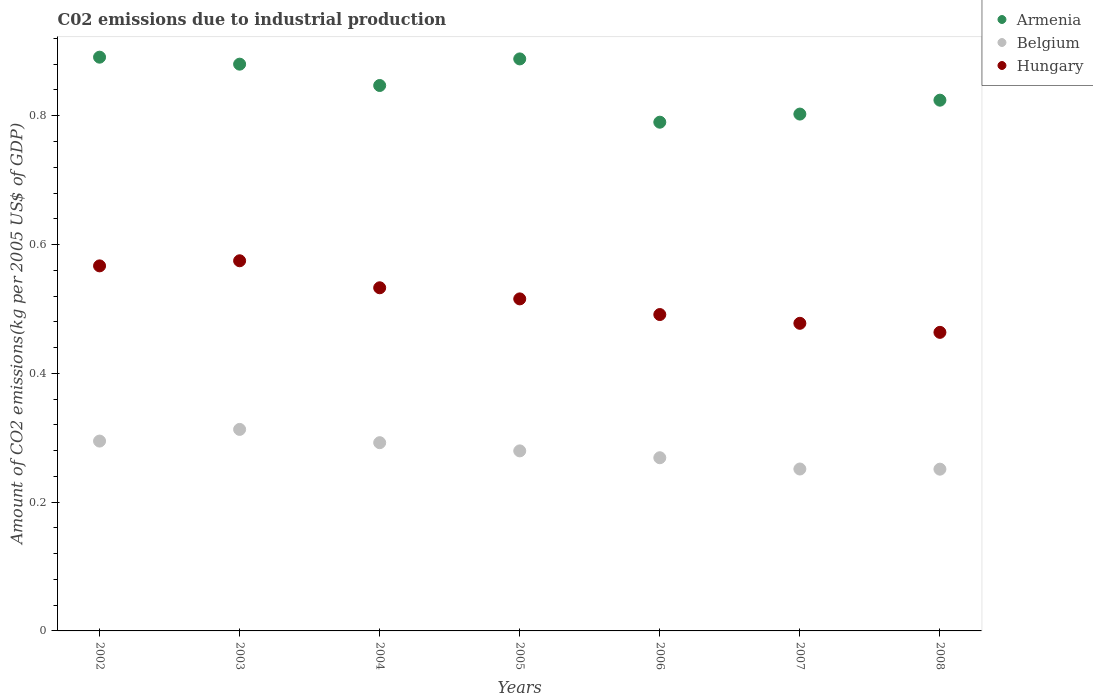Is the number of dotlines equal to the number of legend labels?
Offer a terse response. Yes. What is the amount of CO2 emitted due to industrial production in Belgium in 2005?
Your answer should be compact. 0.28. Across all years, what is the maximum amount of CO2 emitted due to industrial production in Hungary?
Your response must be concise. 0.57. Across all years, what is the minimum amount of CO2 emitted due to industrial production in Belgium?
Provide a succinct answer. 0.25. In which year was the amount of CO2 emitted due to industrial production in Belgium minimum?
Provide a short and direct response. 2008. What is the total amount of CO2 emitted due to industrial production in Armenia in the graph?
Make the answer very short. 5.92. What is the difference between the amount of CO2 emitted due to industrial production in Hungary in 2003 and that in 2006?
Your answer should be compact. 0.08. What is the difference between the amount of CO2 emitted due to industrial production in Armenia in 2003 and the amount of CO2 emitted due to industrial production in Belgium in 2007?
Offer a terse response. 0.63. What is the average amount of CO2 emitted due to industrial production in Belgium per year?
Make the answer very short. 0.28. In the year 2003, what is the difference between the amount of CO2 emitted due to industrial production in Hungary and amount of CO2 emitted due to industrial production in Belgium?
Your answer should be compact. 0.26. In how many years, is the amount of CO2 emitted due to industrial production in Belgium greater than 0.6400000000000001 kg?
Ensure brevity in your answer.  0. What is the ratio of the amount of CO2 emitted due to industrial production in Hungary in 2004 to that in 2007?
Your response must be concise. 1.12. Is the amount of CO2 emitted due to industrial production in Armenia in 2004 less than that in 2007?
Keep it short and to the point. No. Is the difference between the amount of CO2 emitted due to industrial production in Hungary in 2006 and 2007 greater than the difference between the amount of CO2 emitted due to industrial production in Belgium in 2006 and 2007?
Provide a short and direct response. No. What is the difference between the highest and the second highest amount of CO2 emitted due to industrial production in Belgium?
Provide a short and direct response. 0.02. What is the difference between the highest and the lowest amount of CO2 emitted due to industrial production in Armenia?
Make the answer very short. 0.1. In how many years, is the amount of CO2 emitted due to industrial production in Belgium greater than the average amount of CO2 emitted due to industrial production in Belgium taken over all years?
Your answer should be very brief. 4. Does the amount of CO2 emitted due to industrial production in Armenia monotonically increase over the years?
Ensure brevity in your answer.  No. Does the graph contain grids?
Provide a short and direct response. No. How are the legend labels stacked?
Your answer should be very brief. Vertical. What is the title of the graph?
Ensure brevity in your answer.  C02 emissions due to industrial production. What is the label or title of the Y-axis?
Ensure brevity in your answer.  Amount of CO2 emissions(kg per 2005 US$ of GDP). What is the Amount of CO2 emissions(kg per 2005 US$ of GDP) of Armenia in 2002?
Ensure brevity in your answer.  0.89. What is the Amount of CO2 emissions(kg per 2005 US$ of GDP) of Belgium in 2002?
Provide a succinct answer. 0.29. What is the Amount of CO2 emissions(kg per 2005 US$ of GDP) of Hungary in 2002?
Your answer should be compact. 0.57. What is the Amount of CO2 emissions(kg per 2005 US$ of GDP) in Armenia in 2003?
Offer a very short reply. 0.88. What is the Amount of CO2 emissions(kg per 2005 US$ of GDP) in Belgium in 2003?
Make the answer very short. 0.31. What is the Amount of CO2 emissions(kg per 2005 US$ of GDP) of Hungary in 2003?
Your answer should be very brief. 0.57. What is the Amount of CO2 emissions(kg per 2005 US$ of GDP) of Armenia in 2004?
Provide a short and direct response. 0.85. What is the Amount of CO2 emissions(kg per 2005 US$ of GDP) of Belgium in 2004?
Make the answer very short. 0.29. What is the Amount of CO2 emissions(kg per 2005 US$ of GDP) in Hungary in 2004?
Your answer should be very brief. 0.53. What is the Amount of CO2 emissions(kg per 2005 US$ of GDP) in Armenia in 2005?
Your response must be concise. 0.89. What is the Amount of CO2 emissions(kg per 2005 US$ of GDP) of Belgium in 2005?
Provide a succinct answer. 0.28. What is the Amount of CO2 emissions(kg per 2005 US$ of GDP) of Hungary in 2005?
Offer a terse response. 0.52. What is the Amount of CO2 emissions(kg per 2005 US$ of GDP) of Armenia in 2006?
Make the answer very short. 0.79. What is the Amount of CO2 emissions(kg per 2005 US$ of GDP) in Belgium in 2006?
Offer a terse response. 0.27. What is the Amount of CO2 emissions(kg per 2005 US$ of GDP) of Hungary in 2006?
Ensure brevity in your answer.  0.49. What is the Amount of CO2 emissions(kg per 2005 US$ of GDP) in Armenia in 2007?
Ensure brevity in your answer.  0.8. What is the Amount of CO2 emissions(kg per 2005 US$ of GDP) in Belgium in 2007?
Offer a very short reply. 0.25. What is the Amount of CO2 emissions(kg per 2005 US$ of GDP) of Hungary in 2007?
Provide a succinct answer. 0.48. What is the Amount of CO2 emissions(kg per 2005 US$ of GDP) in Armenia in 2008?
Offer a terse response. 0.82. What is the Amount of CO2 emissions(kg per 2005 US$ of GDP) in Belgium in 2008?
Offer a very short reply. 0.25. What is the Amount of CO2 emissions(kg per 2005 US$ of GDP) in Hungary in 2008?
Keep it short and to the point. 0.46. Across all years, what is the maximum Amount of CO2 emissions(kg per 2005 US$ of GDP) in Armenia?
Offer a terse response. 0.89. Across all years, what is the maximum Amount of CO2 emissions(kg per 2005 US$ of GDP) in Belgium?
Your response must be concise. 0.31. Across all years, what is the maximum Amount of CO2 emissions(kg per 2005 US$ of GDP) of Hungary?
Make the answer very short. 0.57. Across all years, what is the minimum Amount of CO2 emissions(kg per 2005 US$ of GDP) of Armenia?
Offer a terse response. 0.79. Across all years, what is the minimum Amount of CO2 emissions(kg per 2005 US$ of GDP) in Belgium?
Ensure brevity in your answer.  0.25. Across all years, what is the minimum Amount of CO2 emissions(kg per 2005 US$ of GDP) in Hungary?
Your answer should be very brief. 0.46. What is the total Amount of CO2 emissions(kg per 2005 US$ of GDP) in Armenia in the graph?
Offer a terse response. 5.92. What is the total Amount of CO2 emissions(kg per 2005 US$ of GDP) in Belgium in the graph?
Your answer should be very brief. 1.95. What is the total Amount of CO2 emissions(kg per 2005 US$ of GDP) in Hungary in the graph?
Offer a terse response. 3.62. What is the difference between the Amount of CO2 emissions(kg per 2005 US$ of GDP) of Armenia in 2002 and that in 2003?
Your answer should be very brief. 0.01. What is the difference between the Amount of CO2 emissions(kg per 2005 US$ of GDP) in Belgium in 2002 and that in 2003?
Your answer should be compact. -0.02. What is the difference between the Amount of CO2 emissions(kg per 2005 US$ of GDP) of Hungary in 2002 and that in 2003?
Provide a short and direct response. -0.01. What is the difference between the Amount of CO2 emissions(kg per 2005 US$ of GDP) of Armenia in 2002 and that in 2004?
Your answer should be compact. 0.04. What is the difference between the Amount of CO2 emissions(kg per 2005 US$ of GDP) in Belgium in 2002 and that in 2004?
Provide a succinct answer. 0. What is the difference between the Amount of CO2 emissions(kg per 2005 US$ of GDP) in Hungary in 2002 and that in 2004?
Keep it short and to the point. 0.03. What is the difference between the Amount of CO2 emissions(kg per 2005 US$ of GDP) in Armenia in 2002 and that in 2005?
Make the answer very short. 0. What is the difference between the Amount of CO2 emissions(kg per 2005 US$ of GDP) of Belgium in 2002 and that in 2005?
Offer a terse response. 0.02. What is the difference between the Amount of CO2 emissions(kg per 2005 US$ of GDP) of Hungary in 2002 and that in 2005?
Your answer should be compact. 0.05. What is the difference between the Amount of CO2 emissions(kg per 2005 US$ of GDP) of Armenia in 2002 and that in 2006?
Make the answer very short. 0.1. What is the difference between the Amount of CO2 emissions(kg per 2005 US$ of GDP) of Belgium in 2002 and that in 2006?
Your answer should be compact. 0.03. What is the difference between the Amount of CO2 emissions(kg per 2005 US$ of GDP) of Hungary in 2002 and that in 2006?
Offer a terse response. 0.08. What is the difference between the Amount of CO2 emissions(kg per 2005 US$ of GDP) in Armenia in 2002 and that in 2007?
Give a very brief answer. 0.09. What is the difference between the Amount of CO2 emissions(kg per 2005 US$ of GDP) of Belgium in 2002 and that in 2007?
Make the answer very short. 0.04. What is the difference between the Amount of CO2 emissions(kg per 2005 US$ of GDP) of Hungary in 2002 and that in 2007?
Make the answer very short. 0.09. What is the difference between the Amount of CO2 emissions(kg per 2005 US$ of GDP) in Armenia in 2002 and that in 2008?
Offer a very short reply. 0.07. What is the difference between the Amount of CO2 emissions(kg per 2005 US$ of GDP) of Belgium in 2002 and that in 2008?
Make the answer very short. 0.04. What is the difference between the Amount of CO2 emissions(kg per 2005 US$ of GDP) in Hungary in 2002 and that in 2008?
Your answer should be compact. 0.1. What is the difference between the Amount of CO2 emissions(kg per 2005 US$ of GDP) of Armenia in 2003 and that in 2004?
Give a very brief answer. 0.03. What is the difference between the Amount of CO2 emissions(kg per 2005 US$ of GDP) of Belgium in 2003 and that in 2004?
Your response must be concise. 0.02. What is the difference between the Amount of CO2 emissions(kg per 2005 US$ of GDP) of Hungary in 2003 and that in 2004?
Your answer should be compact. 0.04. What is the difference between the Amount of CO2 emissions(kg per 2005 US$ of GDP) in Armenia in 2003 and that in 2005?
Offer a very short reply. -0.01. What is the difference between the Amount of CO2 emissions(kg per 2005 US$ of GDP) of Belgium in 2003 and that in 2005?
Your answer should be compact. 0.03. What is the difference between the Amount of CO2 emissions(kg per 2005 US$ of GDP) of Hungary in 2003 and that in 2005?
Keep it short and to the point. 0.06. What is the difference between the Amount of CO2 emissions(kg per 2005 US$ of GDP) of Armenia in 2003 and that in 2006?
Make the answer very short. 0.09. What is the difference between the Amount of CO2 emissions(kg per 2005 US$ of GDP) in Belgium in 2003 and that in 2006?
Provide a succinct answer. 0.04. What is the difference between the Amount of CO2 emissions(kg per 2005 US$ of GDP) of Hungary in 2003 and that in 2006?
Keep it short and to the point. 0.08. What is the difference between the Amount of CO2 emissions(kg per 2005 US$ of GDP) of Armenia in 2003 and that in 2007?
Your answer should be very brief. 0.08. What is the difference between the Amount of CO2 emissions(kg per 2005 US$ of GDP) in Belgium in 2003 and that in 2007?
Ensure brevity in your answer.  0.06. What is the difference between the Amount of CO2 emissions(kg per 2005 US$ of GDP) of Hungary in 2003 and that in 2007?
Give a very brief answer. 0.1. What is the difference between the Amount of CO2 emissions(kg per 2005 US$ of GDP) in Armenia in 2003 and that in 2008?
Give a very brief answer. 0.06. What is the difference between the Amount of CO2 emissions(kg per 2005 US$ of GDP) of Belgium in 2003 and that in 2008?
Offer a terse response. 0.06. What is the difference between the Amount of CO2 emissions(kg per 2005 US$ of GDP) in Hungary in 2003 and that in 2008?
Make the answer very short. 0.11. What is the difference between the Amount of CO2 emissions(kg per 2005 US$ of GDP) in Armenia in 2004 and that in 2005?
Give a very brief answer. -0.04. What is the difference between the Amount of CO2 emissions(kg per 2005 US$ of GDP) in Belgium in 2004 and that in 2005?
Offer a very short reply. 0.01. What is the difference between the Amount of CO2 emissions(kg per 2005 US$ of GDP) in Hungary in 2004 and that in 2005?
Provide a short and direct response. 0.02. What is the difference between the Amount of CO2 emissions(kg per 2005 US$ of GDP) in Armenia in 2004 and that in 2006?
Your response must be concise. 0.06. What is the difference between the Amount of CO2 emissions(kg per 2005 US$ of GDP) of Belgium in 2004 and that in 2006?
Provide a succinct answer. 0.02. What is the difference between the Amount of CO2 emissions(kg per 2005 US$ of GDP) of Hungary in 2004 and that in 2006?
Offer a very short reply. 0.04. What is the difference between the Amount of CO2 emissions(kg per 2005 US$ of GDP) in Armenia in 2004 and that in 2007?
Make the answer very short. 0.04. What is the difference between the Amount of CO2 emissions(kg per 2005 US$ of GDP) of Belgium in 2004 and that in 2007?
Your response must be concise. 0.04. What is the difference between the Amount of CO2 emissions(kg per 2005 US$ of GDP) in Hungary in 2004 and that in 2007?
Your response must be concise. 0.06. What is the difference between the Amount of CO2 emissions(kg per 2005 US$ of GDP) in Armenia in 2004 and that in 2008?
Your answer should be compact. 0.02. What is the difference between the Amount of CO2 emissions(kg per 2005 US$ of GDP) of Belgium in 2004 and that in 2008?
Your answer should be compact. 0.04. What is the difference between the Amount of CO2 emissions(kg per 2005 US$ of GDP) in Hungary in 2004 and that in 2008?
Your answer should be compact. 0.07. What is the difference between the Amount of CO2 emissions(kg per 2005 US$ of GDP) of Armenia in 2005 and that in 2006?
Keep it short and to the point. 0.1. What is the difference between the Amount of CO2 emissions(kg per 2005 US$ of GDP) of Belgium in 2005 and that in 2006?
Your answer should be compact. 0.01. What is the difference between the Amount of CO2 emissions(kg per 2005 US$ of GDP) in Hungary in 2005 and that in 2006?
Offer a terse response. 0.02. What is the difference between the Amount of CO2 emissions(kg per 2005 US$ of GDP) of Armenia in 2005 and that in 2007?
Offer a very short reply. 0.09. What is the difference between the Amount of CO2 emissions(kg per 2005 US$ of GDP) of Belgium in 2005 and that in 2007?
Your response must be concise. 0.03. What is the difference between the Amount of CO2 emissions(kg per 2005 US$ of GDP) of Hungary in 2005 and that in 2007?
Your answer should be very brief. 0.04. What is the difference between the Amount of CO2 emissions(kg per 2005 US$ of GDP) in Armenia in 2005 and that in 2008?
Make the answer very short. 0.06. What is the difference between the Amount of CO2 emissions(kg per 2005 US$ of GDP) in Belgium in 2005 and that in 2008?
Keep it short and to the point. 0.03. What is the difference between the Amount of CO2 emissions(kg per 2005 US$ of GDP) in Hungary in 2005 and that in 2008?
Give a very brief answer. 0.05. What is the difference between the Amount of CO2 emissions(kg per 2005 US$ of GDP) in Armenia in 2006 and that in 2007?
Your response must be concise. -0.01. What is the difference between the Amount of CO2 emissions(kg per 2005 US$ of GDP) in Belgium in 2006 and that in 2007?
Your answer should be very brief. 0.02. What is the difference between the Amount of CO2 emissions(kg per 2005 US$ of GDP) in Hungary in 2006 and that in 2007?
Offer a very short reply. 0.01. What is the difference between the Amount of CO2 emissions(kg per 2005 US$ of GDP) in Armenia in 2006 and that in 2008?
Your response must be concise. -0.03. What is the difference between the Amount of CO2 emissions(kg per 2005 US$ of GDP) of Belgium in 2006 and that in 2008?
Keep it short and to the point. 0.02. What is the difference between the Amount of CO2 emissions(kg per 2005 US$ of GDP) of Hungary in 2006 and that in 2008?
Your answer should be very brief. 0.03. What is the difference between the Amount of CO2 emissions(kg per 2005 US$ of GDP) in Armenia in 2007 and that in 2008?
Ensure brevity in your answer.  -0.02. What is the difference between the Amount of CO2 emissions(kg per 2005 US$ of GDP) in Belgium in 2007 and that in 2008?
Give a very brief answer. 0. What is the difference between the Amount of CO2 emissions(kg per 2005 US$ of GDP) of Hungary in 2007 and that in 2008?
Your answer should be compact. 0.01. What is the difference between the Amount of CO2 emissions(kg per 2005 US$ of GDP) of Armenia in 2002 and the Amount of CO2 emissions(kg per 2005 US$ of GDP) of Belgium in 2003?
Offer a terse response. 0.58. What is the difference between the Amount of CO2 emissions(kg per 2005 US$ of GDP) in Armenia in 2002 and the Amount of CO2 emissions(kg per 2005 US$ of GDP) in Hungary in 2003?
Your answer should be compact. 0.32. What is the difference between the Amount of CO2 emissions(kg per 2005 US$ of GDP) in Belgium in 2002 and the Amount of CO2 emissions(kg per 2005 US$ of GDP) in Hungary in 2003?
Your answer should be compact. -0.28. What is the difference between the Amount of CO2 emissions(kg per 2005 US$ of GDP) in Armenia in 2002 and the Amount of CO2 emissions(kg per 2005 US$ of GDP) in Belgium in 2004?
Offer a terse response. 0.6. What is the difference between the Amount of CO2 emissions(kg per 2005 US$ of GDP) in Armenia in 2002 and the Amount of CO2 emissions(kg per 2005 US$ of GDP) in Hungary in 2004?
Give a very brief answer. 0.36. What is the difference between the Amount of CO2 emissions(kg per 2005 US$ of GDP) of Belgium in 2002 and the Amount of CO2 emissions(kg per 2005 US$ of GDP) of Hungary in 2004?
Keep it short and to the point. -0.24. What is the difference between the Amount of CO2 emissions(kg per 2005 US$ of GDP) in Armenia in 2002 and the Amount of CO2 emissions(kg per 2005 US$ of GDP) in Belgium in 2005?
Make the answer very short. 0.61. What is the difference between the Amount of CO2 emissions(kg per 2005 US$ of GDP) of Armenia in 2002 and the Amount of CO2 emissions(kg per 2005 US$ of GDP) of Hungary in 2005?
Give a very brief answer. 0.38. What is the difference between the Amount of CO2 emissions(kg per 2005 US$ of GDP) of Belgium in 2002 and the Amount of CO2 emissions(kg per 2005 US$ of GDP) of Hungary in 2005?
Offer a terse response. -0.22. What is the difference between the Amount of CO2 emissions(kg per 2005 US$ of GDP) in Armenia in 2002 and the Amount of CO2 emissions(kg per 2005 US$ of GDP) in Belgium in 2006?
Your answer should be compact. 0.62. What is the difference between the Amount of CO2 emissions(kg per 2005 US$ of GDP) of Armenia in 2002 and the Amount of CO2 emissions(kg per 2005 US$ of GDP) of Hungary in 2006?
Offer a very short reply. 0.4. What is the difference between the Amount of CO2 emissions(kg per 2005 US$ of GDP) of Belgium in 2002 and the Amount of CO2 emissions(kg per 2005 US$ of GDP) of Hungary in 2006?
Offer a very short reply. -0.2. What is the difference between the Amount of CO2 emissions(kg per 2005 US$ of GDP) in Armenia in 2002 and the Amount of CO2 emissions(kg per 2005 US$ of GDP) in Belgium in 2007?
Offer a terse response. 0.64. What is the difference between the Amount of CO2 emissions(kg per 2005 US$ of GDP) in Armenia in 2002 and the Amount of CO2 emissions(kg per 2005 US$ of GDP) in Hungary in 2007?
Your answer should be compact. 0.41. What is the difference between the Amount of CO2 emissions(kg per 2005 US$ of GDP) of Belgium in 2002 and the Amount of CO2 emissions(kg per 2005 US$ of GDP) of Hungary in 2007?
Give a very brief answer. -0.18. What is the difference between the Amount of CO2 emissions(kg per 2005 US$ of GDP) in Armenia in 2002 and the Amount of CO2 emissions(kg per 2005 US$ of GDP) in Belgium in 2008?
Provide a short and direct response. 0.64. What is the difference between the Amount of CO2 emissions(kg per 2005 US$ of GDP) of Armenia in 2002 and the Amount of CO2 emissions(kg per 2005 US$ of GDP) of Hungary in 2008?
Give a very brief answer. 0.43. What is the difference between the Amount of CO2 emissions(kg per 2005 US$ of GDP) in Belgium in 2002 and the Amount of CO2 emissions(kg per 2005 US$ of GDP) in Hungary in 2008?
Keep it short and to the point. -0.17. What is the difference between the Amount of CO2 emissions(kg per 2005 US$ of GDP) in Armenia in 2003 and the Amount of CO2 emissions(kg per 2005 US$ of GDP) in Belgium in 2004?
Your answer should be compact. 0.59. What is the difference between the Amount of CO2 emissions(kg per 2005 US$ of GDP) in Armenia in 2003 and the Amount of CO2 emissions(kg per 2005 US$ of GDP) in Hungary in 2004?
Offer a terse response. 0.35. What is the difference between the Amount of CO2 emissions(kg per 2005 US$ of GDP) in Belgium in 2003 and the Amount of CO2 emissions(kg per 2005 US$ of GDP) in Hungary in 2004?
Your response must be concise. -0.22. What is the difference between the Amount of CO2 emissions(kg per 2005 US$ of GDP) in Armenia in 2003 and the Amount of CO2 emissions(kg per 2005 US$ of GDP) in Belgium in 2005?
Provide a short and direct response. 0.6. What is the difference between the Amount of CO2 emissions(kg per 2005 US$ of GDP) in Armenia in 2003 and the Amount of CO2 emissions(kg per 2005 US$ of GDP) in Hungary in 2005?
Give a very brief answer. 0.36. What is the difference between the Amount of CO2 emissions(kg per 2005 US$ of GDP) of Belgium in 2003 and the Amount of CO2 emissions(kg per 2005 US$ of GDP) of Hungary in 2005?
Your answer should be very brief. -0.2. What is the difference between the Amount of CO2 emissions(kg per 2005 US$ of GDP) of Armenia in 2003 and the Amount of CO2 emissions(kg per 2005 US$ of GDP) of Belgium in 2006?
Your answer should be compact. 0.61. What is the difference between the Amount of CO2 emissions(kg per 2005 US$ of GDP) of Armenia in 2003 and the Amount of CO2 emissions(kg per 2005 US$ of GDP) of Hungary in 2006?
Offer a very short reply. 0.39. What is the difference between the Amount of CO2 emissions(kg per 2005 US$ of GDP) of Belgium in 2003 and the Amount of CO2 emissions(kg per 2005 US$ of GDP) of Hungary in 2006?
Make the answer very short. -0.18. What is the difference between the Amount of CO2 emissions(kg per 2005 US$ of GDP) of Armenia in 2003 and the Amount of CO2 emissions(kg per 2005 US$ of GDP) of Belgium in 2007?
Provide a short and direct response. 0.63. What is the difference between the Amount of CO2 emissions(kg per 2005 US$ of GDP) in Armenia in 2003 and the Amount of CO2 emissions(kg per 2005 US$ of GDP) in Hungary in 2007?
Your answer should be very brief. 0.4. What is the difference between the Amount of CO2 emissions(kg per 2005 US$ of GDP) in Belgium in 2003 and the Amount of CO2 emissions(kg per 2005 US$ of GDP) in Hungary in 2007?
Your answer should be compact. -0.16. What is the difference between the Amount of CO2 emissions(kg per 2005 US$ of GDP) of Armenia in 2003 and the Amount of CO2 emissions(kg per 2005 US$ of GDP) of Belgium in 2008?
Your response must be concise. 0.63. What is the difference between the Amount of CO2 emissions(kg per 2005 US$ of GDP) of Armenia in 2003 and the Amount of CO2 emissions(kg per 2005 US$ of GDP) of Hungary in 2008?
Your response must be concise. 0.42. What is the difference between the Amount of CO2 emissions(kg per 2005 US$ of GDP) in Belgium in 2003 and the Amount of CO2 emissions(kg per 2005 US$ of GDP) in Hungary in 2008?
Give a very brief answer. -0.15. What is the difference between the Amount of CO2 emissions(kg per 2005 US$ of GDP) in Armenia in 2004 and the Amount of CO2 emissions(kg per 2005 US$ of GDP) in Belgium in 2005?
Your answer should be compact. 0.57. What is the difference between the Amount of CO2 emissions(kg per 2005 US$ of GDP) of Armenia in 2004 and the Amount of CO2 emissions(kg per 2005 US$ of GDP) of Hungary in 2005?
Provide a short and direct response. 0.33. What is the difference between the Amount of CO2 emissions(kg per 2005 US$ of GDP) of Belgium in 2004 and the Amount of CO2 emissions(kg per 2005 US$ of GDP) of Hungary in 2005?
Your answer should be very brief. -0.22. What is the difference between the Amount of CO2 emissions(kg per 2005 US$ of GDP) of Armenia in 2004 and the Amount of CO2 emissions(kg per 2005 US$ of GDP) of Belgium in 2006?
Give a very brief answer. 0.58. What is the difference between the Amount of CO2 emissions(kg per 2005 US$ of GDP) of Armenia in 2004 and the Amount of CO2 emissions(kg per 2005 US$ of GDP) of Hungary in 2006?
Your answer should be compact. 0.36. What is the difference between the Amount of CO2 emissions(kg per 2005 US$ of GDP) in Belgium in 2004 and the Amount of CO2 emissions(kg per 2005 US$ of GDP) in Hungary in 2006?
Give a very brief answer. -0.2. What is the difference between the Amount of CO2 emissions(kg per 2005 US$ of GDP) of Armenia in 2004 and the Amount of CO2 emissions(kg per 2005 US$ of GDP) of Belgium in 2007?
Provide a succinct answer. 0.6. What is the difference between the Amount of CO2 emissions(kg per 2005 US$ of GDP) in Armenia in 2004 and the Amount of CO2 emissions(kg per 2005 US$ of GDP) in Hungary in 2007?
Provide a short and direct response. 0.37. What is the difference between the Amount of CO2 emissions(kg per 2005 US$ of GDP) in Belgium in 2004 and the Amount of CO2 emissions(kg per 2005 US$ of GDP) in Hungary in 2007?
Offer a very short reply. -0.19. What is the difference between the Amount of CO2 emissions(kg per 2005 US$ of GDP) in Armenia in 2004 and the Amount of CO2 emissions(kg per 2005 US$ of GDP) in Belgium in 2008?
Make the answer very short. 0.6. What is the difference between the Amount of CO2 emissions(kg per 2005 US$ of GDP) of Armenia in 2004 and the Amount of CO2 emissions(kg per 2005 US$ of GDP) of Hungary in 2008?
Your answer should be compact. 0.38. What is the difference between the Amount of CO2 emissions(kg per 2005 US$ of GDP) in Belgium in 2004 and the Amount of CO2 emissions(kg per 2005 US$ of GDP) in Hungary in 2008?
Provide a short and direct response. -0.17. What is the difference between the Amount of CO2 emissions(kg per 2005 US$ of GDP) in Armenia in 2005 and the Amount of CO2 emissions(kg per 2005 US$ of GDP) in Belgium in 2006?
Give a very brief answer. 0.62. What is the difference between the Amount of CO2 emissions(kg per 2005 US$ of GDP) in Armenia in 2005 and the Amount of CO2 emissions(kg per 2005 US$ of GDP) in Hungary in 2006?
Offer a very short reply. 0.4. What is the difference between the Amount of CO2 emissions(kg per 2005 US$ of GDP) in Belgium in 2005 and the Amount of CO2 emissions(kg per 2005 US$ of GDP) in Hungary in 2006?
Give a very brief answer. -0.21. What is the difference between the Amount of CO2 emissions(kg per 2005 US$ of GDP) in Armenia in 2005 and the Amount of CO2 emissions(kg per 2005 US$ of GDP) in Belgium in 2007?
Provide a short and direct response. 0.64. What is the difference between the Amount of CO2 emissions(kg per 2005 US$ of GDP) in Armenia in 2005 and the Amount of CO2 emissions(kg per 2005 US$ of GDP) in Hungary in 2007?
Your response must be concise. 0.41. What is the difference between the Amount of CO2 emissions(kg per 2005 US$ of GDP) of Belgium in 2005 and the Amount of CO2 emissions(kg per 2005 US$ of GDP) of Hungary in 2007?
Offer a terse response. -0.2. What is the difference between the Amount of CO2 emissions(kg per 2005 US$ of GDP) in Armenia in 2005 and the Amount of CO2 emissions(kg per 2005 US$ of GDP) in Belgium in 2008?
Make the answer very short. 0.64. What is the difference between the Amount of CO2 emissions(kg per 2005 US$ of GDP) in Armenia in 2005 and the Amount of CO2 emissions(kg per 2005 US$ of GDP) in Hungary in 2008?
Offer a very short reply. 0.42. What is the difference between the Amount of CO2 emissions(kg per 2005 US$ of GDP) of Belgium in 2005 and the Amount of CO2 emissions(kg per 2005 US$ of GDP) of Hungary in 2008?
Give a very brief answer. -0.18. What is the difference between the Amount of CO2 emissions(kg per 2005 US$ of GDP) of Armenia in 2006 and the Amount of CO2 emissions(kg per 2005 US$ of GDP) of Belgium in 2007?
Offer a terse response. 0.54. What is the difference between the Amount of CO2 emissions(kg per 2005 US$ of GDP) in Armenia in 2006 and the Amount of CO2 emissions(kg per 2005 US$ of GDP) in Hungary in 2007?
Make the answer very short. 0.31. What is the difference between the Amount of CO2 emissions(kg per 2005 US$ of GDP) in Belgium in 2006 and the Amount of CO2 emissions(kg per 2005 US$ of GDP) in Hungary in 2007?
Your response must be concise. -0.21. What is the difference between the Amount of CO2 emissions(kg per 2005 US$ of GDP) in Armenia in 2006 and the Amount of CO2 emissions(kg per 2005 US$ of GDP) in Belgium in 2008?
Make the answer very short. 0.54. What is the difference between the Amount of CO2 emissions(kg per 2005 US$ of GDP) in Armenia in 2006 and the Amount of CO2 emissions(kg per 2005 US$ of GDP) in Hungary in 2008?
Ensure brevity in your answer.  0.33. What is the difference between the Amount of CO2 emissions(kg per 2005 US$ of GDP) of Belgium in 2006 and the Amount of CO2 emissions(kg per 2005 US$ of GDP) of Hungary in 2008?
Your response must be concise. -0.19. What is the difference between the Amount of CO2 emissions(kg per 2005 US$ of GDP) of Armenia in 2007 and the Amount of CO2 emissions(kg per 2005 US$ of GDP) of Belgium in 2008?
Keep it short and to the point. 0.55. What is the difference between the Amount of CO2 emissions(kg per 2005 US$ of GDP) of Armenia in 2007 and the Amount of CO2 emissions(kg per 2005 US$ of GDP) of Hungary in 2008?
Provide a succinct answer. 0.34. What is the difference between the Amount of CO2 emissions(kg per 2005 US$ of GDP) in Belgium in 2007 and the Amount of CO2 emissions(kg per 2005 US$ of GDP) in Hungary in 2008?
Your response must be concise. -0.21. What is the average Amount of CO2 emissions(kg per 2005 US$ of GDP) of Armenia per year?
Make the answer very short. 0.85. What is the average Amount of CO2 emissions(kg per 2005 US$ of GDP) of Belgium per year?
Your answer should be very brief. 0.28. What is the average Amount of CO2 emissions(kg per 2005 US$ of GDP) in Hungary per year?
Ensure brevity in your answer.  0.52. In the year 2002, what is the difference between the Amount of CO2 emissions(kg per 2005 US$ of GDP) in Armenia and Amount of CO2 emissions(kg per 2005 US$ of GDP) in Belgium?
Offer a very short reply. 0.6. In the year 2002, what is the difference between the Amount of CO2 emissions(kg per 2005 US$ of GDP) in Armenia and Amount of CO2 emissions(kg per 2005 US$ of GDP) in Hungary?
Offer a terse response. 0.32. In the year 2002, what is the difference between the Amount of CO2 emissions(kg per 2005 US$ of GDP) in Belgium and Amount of CO2 emissions(kg per 2005 US$ of GDP) in Hungary?
Provide a short and direct response. -0.27. In the year 2003, what is the difference between the Amount of CO2 emissions(kg per 2005 US$ of GDP) in Armenia and Amount of CO2 emissions(kg per 2005 US$ of GDP) in Belgium?
Ensure brevity in your answer.  0.57. In the year 2003, what is the difference between the Amount of CO2 emissions(kg per 2005 US$ of GDP) in Armenia and Amount of CO2 emissions(kg per 2005 US$ of GDP) in Hungary?
Make the answer very short. 0.31. In the year 2003, what is the difference between the Amount of CO2 emissions(kg per 2005 US$ of GDP) in Belgium and Amount of CO2 emissions(kg per 2005 US$ of GDP) in Hungary?
Provide a succinct answer. -0.26. In the year 2004, what is the difference between the Amount of CO2 emissions(kg per 2005 US$ of GDP) in Armenia and Amount of CO2 emissions(kg per 2005 US$ of GDP) in Belgium?
Keep it short and to the point. 0.55. In the year 2004, what is the difference between the Amount of CO2 emissions(kg per 2005 US$ of GDP) in Armenia and Amount of CO2 emissions(kg per 2005 US$ of GDP) in Hungary?
Give a very brief answer. 0.31. In the year 2004, what is the difference between the Amount of CO2 emissions(kg per 2005 US$ of GDP) of Belgium and Amount of CO2 emissions(kg per 2005 US$ of GDP) of Hungary?
Provide a short and direct response. -0.24. In the year 2005, what is the difference between the Amount of CO2 emissions(kg per 2005 US$ of GDP) of Armenia and Amount of CO2 emissions(kg per 2005 US$ of GDP) of Belgium?
Offer a very short reply. 0.61. In the year 2005, what is the difference between the Amount of CO2 emissions(kg per 2005 US$ of GDP) of Armenia and Amount of CO2 emissions(kg per 2005 US$ of GDP) of Hungary?
Keep it short and to the point. 0.37. In the year 2005, what is the difference between the Amount of CO2 emissions(kg per 2005 US$ of GDP) in Belgium and Amount of CO2 emissions(kg per 2005 US$ of GDP) in Hungary?
Provide a succinct answer. -0.24. In the year 2006, what is the difference between the Amount of CO2 emissions(kg per 2005 US$ of GDP) in Armenia and Amount of CO2 emissions(kg per 2005 US$ of GDP) in Belgium?
Provide a short and direct response. 0.52. In the year 2006, what is the difference between the Amount of CO2 emissions(kg per 2005 US$ of GDP) of Armenia and Amount of CO2 emissions(kg per 2005 US$ of GDP) of Hungary?
Your response must be concise. 0.3. In the year 2006, what is the difference between the Amount of CO2 emissions(kg per 2005 US$ of GDP) in Belgium and Amount of CO2 emissions(kg per 2005 US$ of GDP) in Hungary?
Give a very brief answer. -0.22. In the year 2007, what is the difference between the Amount of CO2 emissions(kg per 2005 US$ of GDP) in Armenia and Amount of CO2 emissions(kg per 2005 US$ of GDP) in Belgium?
Offer a terse response. 0.55. In the year 2007, what is the difference between the Amount of CO2 emissions(kg per 2005 US$ of GDP) in Armenia and Amount of CO2 emissions(kg per 2005 US$ of GDP) in Hungary?
Give a very brief answer. 0.32. In the year 2007, what is the difference between the Amount of CO2 emissions(kg per 2005 US$ of GDP) in Belgium and Amount of CO2 emissions(kg per 2005 US$ of GDP) in Hungary?
Your response must be concise. -0.23. In the year 2008, what is the difference between the Amount of CO2 emissions(kg per 2005 US$ of GDP) of Armenia and Amount of CO2 emissions(kg per 2005 US$ of GDP) of Belgium?
Offer a very short reply. 0.57. In the year 2008, what is the difference between the Amount of CO2 emissions(kg per 2005 US$ of GDP) in Armenia and Amount of CO2 emissions(kg per 2005 US$ of GDP) in Hungary?
Keep it short and to the point. 0.36. In the year 2008, what is the difference between the Amount of CO2 emissions(kg per 2005 US$ of GDP) of Belgium and Amount of CO2 emissions(kg per 2005 US$ of GDP) of Hungary?
Offer a terse response. -0.21. What is the ratio of the Amount of CO2 emissions(kg per 2005 US$ of GDP) of Armenia in 2002 to that in 2003?
Provide a succinct answer. 1.01. What is the ratio of the Amount of CO2 emissions(kg per 2005 US$ of GDP) in Belgium in 2002 to that in 2003?
Your answer should be very brief. 0.94. What is the ratio of the Amount of CO2 emissions(kg per 2005 US$ of GDP) in Hungary in 2002 to that in 2003?
Your answer should be very brief. 0.99. What is the ratio of the Amount of CO2 emissions(kg per 2005 US$ of GDP) of Armenia in 2002 to that in 2004?
Provide a succinct answer. 1.05. What is the ratio of the Amount of CO2 emissions(kg per 2005 US$ of GDP) in Belgium in 2002 to that in 2004?
Give a very brief answer. 1.01. What is the ratio of the Amount of CO2 emissions(kg per 2005 US$ of GDP) in Hungary in 2002 to that in 2004?
Make the answer very short. 1.06. What is the ratio of the Amount of CO2 emissions(kg per 2005 US$ of GDP) of Belgium in 2002 to that in 2005?
Ensure brevity in your answer.  1.05. What is the ratio of the Amount of CO2 emissions(kg per 2005 US$ of GDP) of Hungary in 2002 to that in 2005?
Your answer should be compact. 1.1. What is the ratio of the Amount of CO2 emissions(kg per 2005 US$ of GDP) in Armenia in 2002 to that in 2006?
Your answer should be very brief. 1.13. What is the ratio of the Amount of CO2 emissions(kg per 2005 US$ of GDP) in Belgium in 2002 to that in 2006?
Your answer should be very brief. 1.1. What is the ratio of the Amount of CO2 emissions(kg per 2005 US$ of GDP) of Hungary in 2002 to that in 2006?
Your response must be concise. 1.15. What is the ratio of the Amount of CO2 emissions(kg per 2005 US$ of GDP) in Armenia in 2002 to that in 2007?
Keep it short and to the point. 1.11. What is the ratio of the Amount of CO2 emissions(kg per 2005 US$ of GDP) of Belgium in 2002 to that in 2007?
Ensure brevity in your answer.  1.17. What is the ratio of the Amount of CO2 emissions(kg per 2005 US$ of GDP) in Hungary in 2002 to that in 2007?
Your answer should be compact. 1.19. What is the ratio of the Amount of CO2 emissions(kg per 2005 US$ of GDP) of Armenia in 2002 to that in 2008?
Ensure brevity in your answer.  1.08. What is the ratio of the Amount of CO2 emissions(kg per 2005 US$ of GDP) in Belgium in 2002 to that in 2008?
Offer a very short reply. 1.17. What is the ratio of the Amount of CO2 emissions(kg per 2005 US$ of GDP) in Hungary in 2002 to that in 2008?
Your answer should be very brief. 1.22. What is the ratio of the Amount of CO2 emissions(kg per 2005 US$ of GDP) of Armenia in 2003 to that in 2004?
Offer a very short reply. 1.04. What is the ratio of the Amount of CO2 emissions(kg per 2005 US$ of GDP) of Belgium in 2003 to that in 2004?
Your answer should be compact. 1.07. What is the ratio of the Amount of CO2 emissions(kg per 2005 US$ of GDP) of Hungary in 2003 to that in 2004?
Ensure brevity in your answer.  1.08. What is the ratio of the Amount of CO2 emissions(kg per 2005 US$ of GDP) in Armenia in 2003 to that in 2005?
Give a very brief answer. 0.99. What is the ratio of the Amount of CO2 emissions(kg per 2005 US$ of GDP) in Belgium in 2003 to that in 2005?
Offer a very short reply. 1.12. What is the ratio of the Amount of CO2 emissions(kg per 2005 US$ of GDP) of Hungary in 2003 to that in 2005?
Make the answer very short. 1.11. What is the ratio of the Amount of CO2 emissions(kg per 2005 US$ of GDP) of Armenia in 2003 to that in 2006?
Make the answer very short. 1.11. What is the ratio of the Amount of CO2 emissions(kg per 2005 US$ of GDP) in Belgium in 2003 to that in 2006?
Provide a succinct answer. 1.16. What is the ratio of the Amount of CO2 emissions(kg per 2005 US$ of GDP) of Hungary in 2003 to that in 2006?
Make the answer very short. 1.17. What is the ratio of the Amount of CO2 emissions(kg per 2005 US$ of GDP) in Armenia in 2003 to that in 2007?
Your response must be concise. 1.1. What is the ratio of the Amount of CO2 emissions(kg per 2005 US$ of GDP) in Belgium in 2003 to that in 2007?
Provide a succinct answer. 1.24. What is the ratio of the Amount of CO2 emissions(kg per 2005 US$ of GDP) in Hungary in 2003 to that in 2007?
Keep it short and to the point. 1.2. What is the ratio of the Amount of CO2 emissions(kg per 2005 US$ of GDP) in Armenia in 2003 to that in 2008?
Your response must be concise. 1.07. What is the ratio of the Amount of CO2 emissions(kg per 2005 US$ of GDP) of Belgium in 2003 to that in 2008?
Give a very brief answer. 1.25. What is the ratio of the Amount of CO2 emissions(kg per 2005 US$ of GDP) in Hungary in 2003 to that in 2008?
Your response must be concise. 1.24. What is the ratio of the Amount of CO2 emissions(kg per 2005 US$ of GDP) of Armenia in 2004 to that in 2005?
Provide a succinct answer. 0.95. What is the ratio of the Amount of CO2 emissions(kg per 2005 US$ of GDP) of Belgium in 2004 to that in 2005?
Provide a succinct answer. 1.05. What is the ratio of the Amount of CO2 emissions(kg per 2005 US$ of GDP) in Hungary in 2004 to that in 2005?
Make the answer very short. 1.03. What is the ratio of the Amount of CO2 emissions(kg per 2005 US$ of GDP) of Armenia in 2004 to that in 2006?
Keep it short and to the point. 1.07. What is the ratio of the Amount of CO2 emissions(kg per 2005 US$ of GDP) of Belgium in 2004 to that in 2006?
Offer a very short reply. 1.09. What is the ratio of the Amount of CO2 emissions(kg per 2005 US$ of GDP) in Hungary in 2004 to that in 2006?
Offer a very short reply. 1.08. What is the ratio of the Amount of CO2 emissions(kg per 2005 US$ of GDP) in Armenia in 2004 to that in 2007?
Keep it short and to the point. 1.06. What is the ratio of the Amount of CO2 emissions(kg per 2005 US$ of GDP) in Belgium in 2004 to that in 2007?
Provide a short and direct response. 1.16. What is the ratio of the Amount of CO2 emissions(kg per 2005 US$ of GDP) in Hungary in 2004 to that in 2007?
Your answer should be compact. 1.12. What is the ratio of the Amount of CO2 emissions(kg per 2005 US$ of GDP) of Armenia in 2004 to that in 2008?
Offer a terse response. 1.03. What is the ratio of the Amount of CO2 emissions(kg per 2005 US$ of GDP) in Belgium in 2004 to that in 2008?
Your answer should be compact. 1.16. What is the ratio of the Amount of CO2 emissions(kg per 2005 US$ of GDP) of Hungary in 2004 to that in 2008?
Your answer should be very brief. 1.15. What is the ratio of the Amount of CO2 emissions(kg per 2005 US$ of GDP) of Armenia in 2005 to that in 2006?
Offer a terse response. 1.12. What is the ratio of the Amount of CO2 emissions(kg per 2005 US$ of GDP) in Belgium in 2005 to that in 2006?
Give a very brief answer. 1.04. What is the ratio of the Amount of CO2 emissions(kg per 2005 US$ of GDP) in Hungary in 2005 to that in 2006?
Your answer should be very brief. 1.05. What is the ratio of the Amount of CO2 emissions(kg per 2005 US$ of GDP) in Armenia in 2005 to that in 2007?
Give a very brief answer. 1.11. What is the ratio of the Amount of CO2 emissions(kg per 2005 US$ of GDP) of Belgium in 2005 to that in 2007?
Your answer should be compact. 1.11. What is the ratio of the Amount of CO2 emissions(kg per 2005 US$ of GDP) in Hungary in 2005 to that in 2007?
Keep it short and to the point. 1.08. What is the ratio of the Amount of CO2 emissions(kg per 2005 US$ of GDP) of Armenia in 2005 to that in 2008?
Ensure brevity in your answer.  1.08. What is the ratio of the Amount of CO2 emissions(kg per 2005 US$ of GDP) of Belgium in 2005 to that in 2008?
Ensure brevity in your answer.  1.11. What is the ratio of the Amount of CO2 emissions(kg per 2005 US$ of GDP) in Hungary in 2005 to that in 2008?
Provide a succinct answer. 1.11. What is the ratio of the Amount of CO2 emissions(kg per 2005 US$ of GDP) of Armenia in 2006 to that in 2007?
Provide a short and direct response. 0.98. What is the ratio of the Amount of CO2 emissions(kg per 2005 US$ of GDP) in Belgium in 2006 to that in 2007?
Provide a succinct answer. 1.07. What is the ratio of the Amount of CO2 emissions(kg per 2005 US$ of GDP) of Hungary in 2006 to that in 2007?
Give a very brief answer. 1.03. What is the ratio of the Amount of CO2 emissions(kg per 2005 US$ of GDP) of Armenia in 2006 to that in 2008?
Give a very brief answer. 0.96. What is the ratio of the Amount of CO2 emissions(kg per 2005 US$ of GDP) in Belgium in 2006 to that in 2008?
Ensure brevity in your answer.  1.07. What is the ratio of the Amount of CO2 emissions(kg per 2005 US$ of GDP) in Hungary in 2006 to that in 2008?
Ensure brevity in your answer.  1.06. What is the ratio of the Amount of CO2 emissions(kg per 2005 US$ of GDP) of Armenia in 2007 to that in 2008?
Provide a succinct answer. 0.97. What is the ratio of the Amount of CO2 emissions(kg per 2005 US$ of GDP) in Hungary in 2007 to that in 2008?
Keep it short and to the point. 1.03. What is the difference between the highest and the second highest Amount of CO2 emissions(kg per 2005 US$ of GDP) in Armenia?
Your answer should be compact. 0. What is the difference between the highest and the second highest Amount of CO2 emissions(kg per 2005 US$ of GDP) of Belgium?
Your response must be concise. 0.02. What is the difference between the highest and the second highest Amount of CO2 emissions(kg per 2005 US$ of GDP) of Hungary?
Provide a succinct answer. 0.01. What is the difference between the highest and the lowest Amount of CO2 emissions(kg per 2005 US$ of GDP) of Armenia?
Provide a succinct answer. 0.1. What is the difference between the highest and the lowest Amount of CO2 emissions(kg per 2005 US$ of GDP) in Belgium?
Provide a short and direct response. 0.06. What is the difference between the highest and the lowest Amount of CO2 emissions(kg per 2005 US$ of GDP) in Hungary?
Your answer should be very brief. 0.11. 